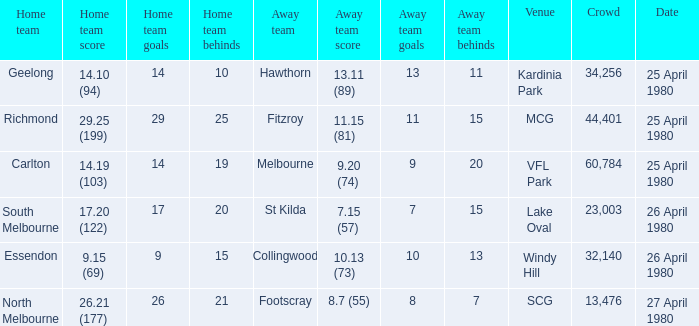What was the lowest crowd size at MCG? 44401.0. 